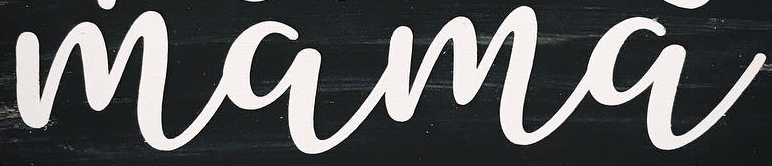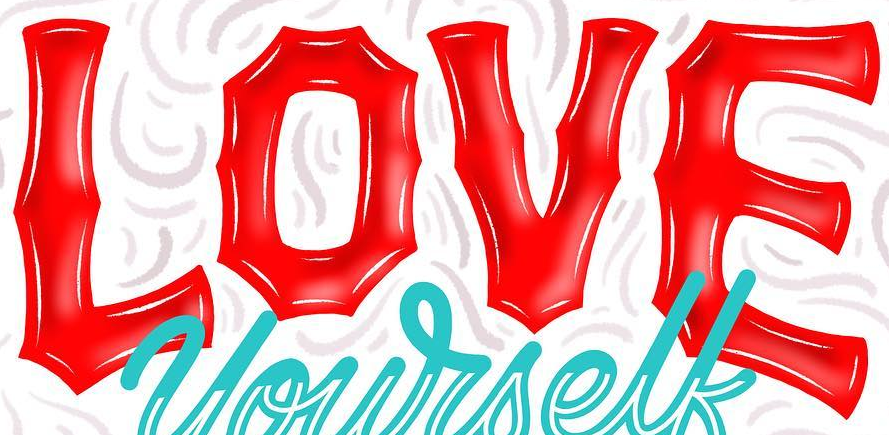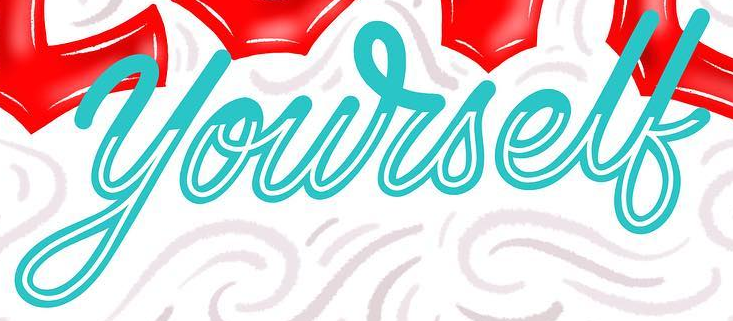Read the text content from these images in order, separated by a semicolon. mama; LOVE; yourself 